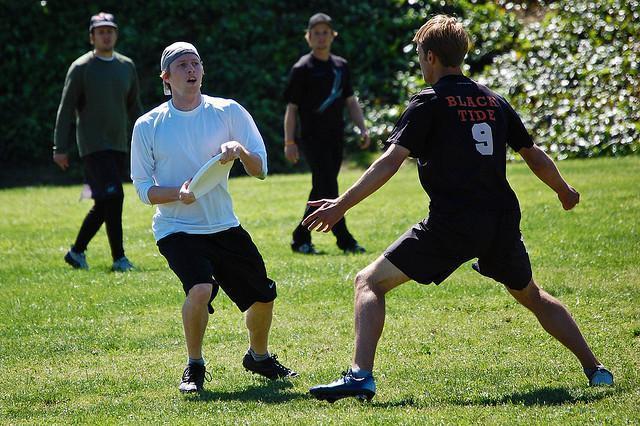How many people are there?
Give a very brief answer. 4. How many airplanes are there?
Give a very brief answer. 0. 